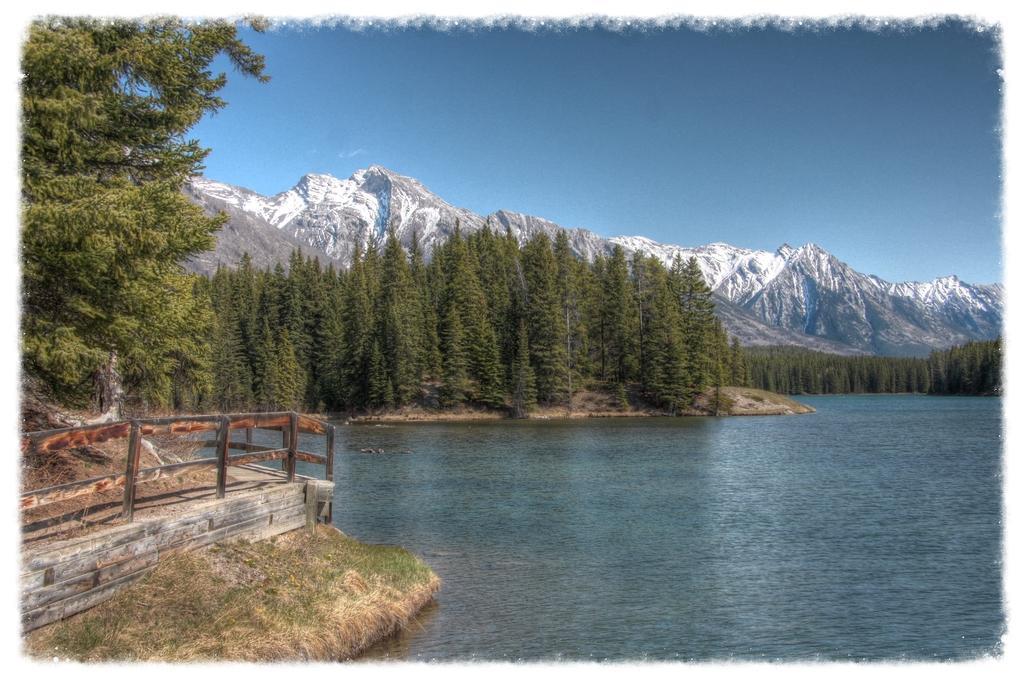Can you describe this image briefly? This is the picture of a lake with some trees around it and to the side of the lake there is a bridge. In the background, there are some trees and mountains. 